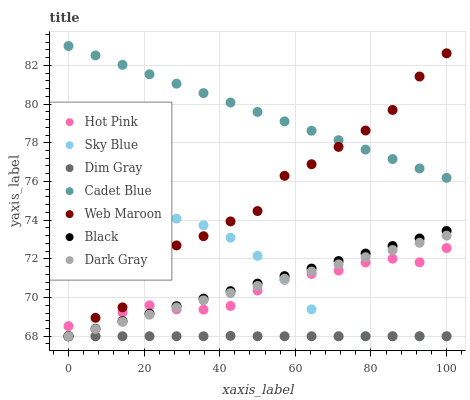Does Dim Gray have the minimum area under the curve?
Answer yes or no. Yes. Does Cadet Blue have the maximum area under the curve?
Answer yes or no. Yes. Does Hot Pink have the minimum area under the curve?
Answer yes or no. No. Does Hot Pink have the maximum area under the curve?
Answer yes or no. No. Is Dark Gray the smoothest?
Answer yes or no. Yes. Is Web Maroon the roughest?
Answer yes or no. Yes. Is Hot Pink the smoothest?
Answer yes or no. No. Is Hot Pink the roughest?
Answer yes or no. No. Does Hot Pink have the lowest value?
Answer yes or no. Yes. Does Cadet Blue have the highest value?
Answer yes or no. Yes. Does Hot Pink have the highest value?
Answer yes or no. No. Is Dim Gray less than Cadet Blue?
Answer yes or no. Yes. Is Cadet Blue greater than Hot Pink?
Answer yes or no. Yes. Does Web Maroon intersect Hot Pink?
Answer yes or no. Yes. Is Web Maroon less than Hot Pink?
Answer yes or no. No. Is Web Maroon greater than Hot Pink?
Answer yes or no. No. Does Dim Gray intersect Cadet Blue?
Answer yes or no. No. 